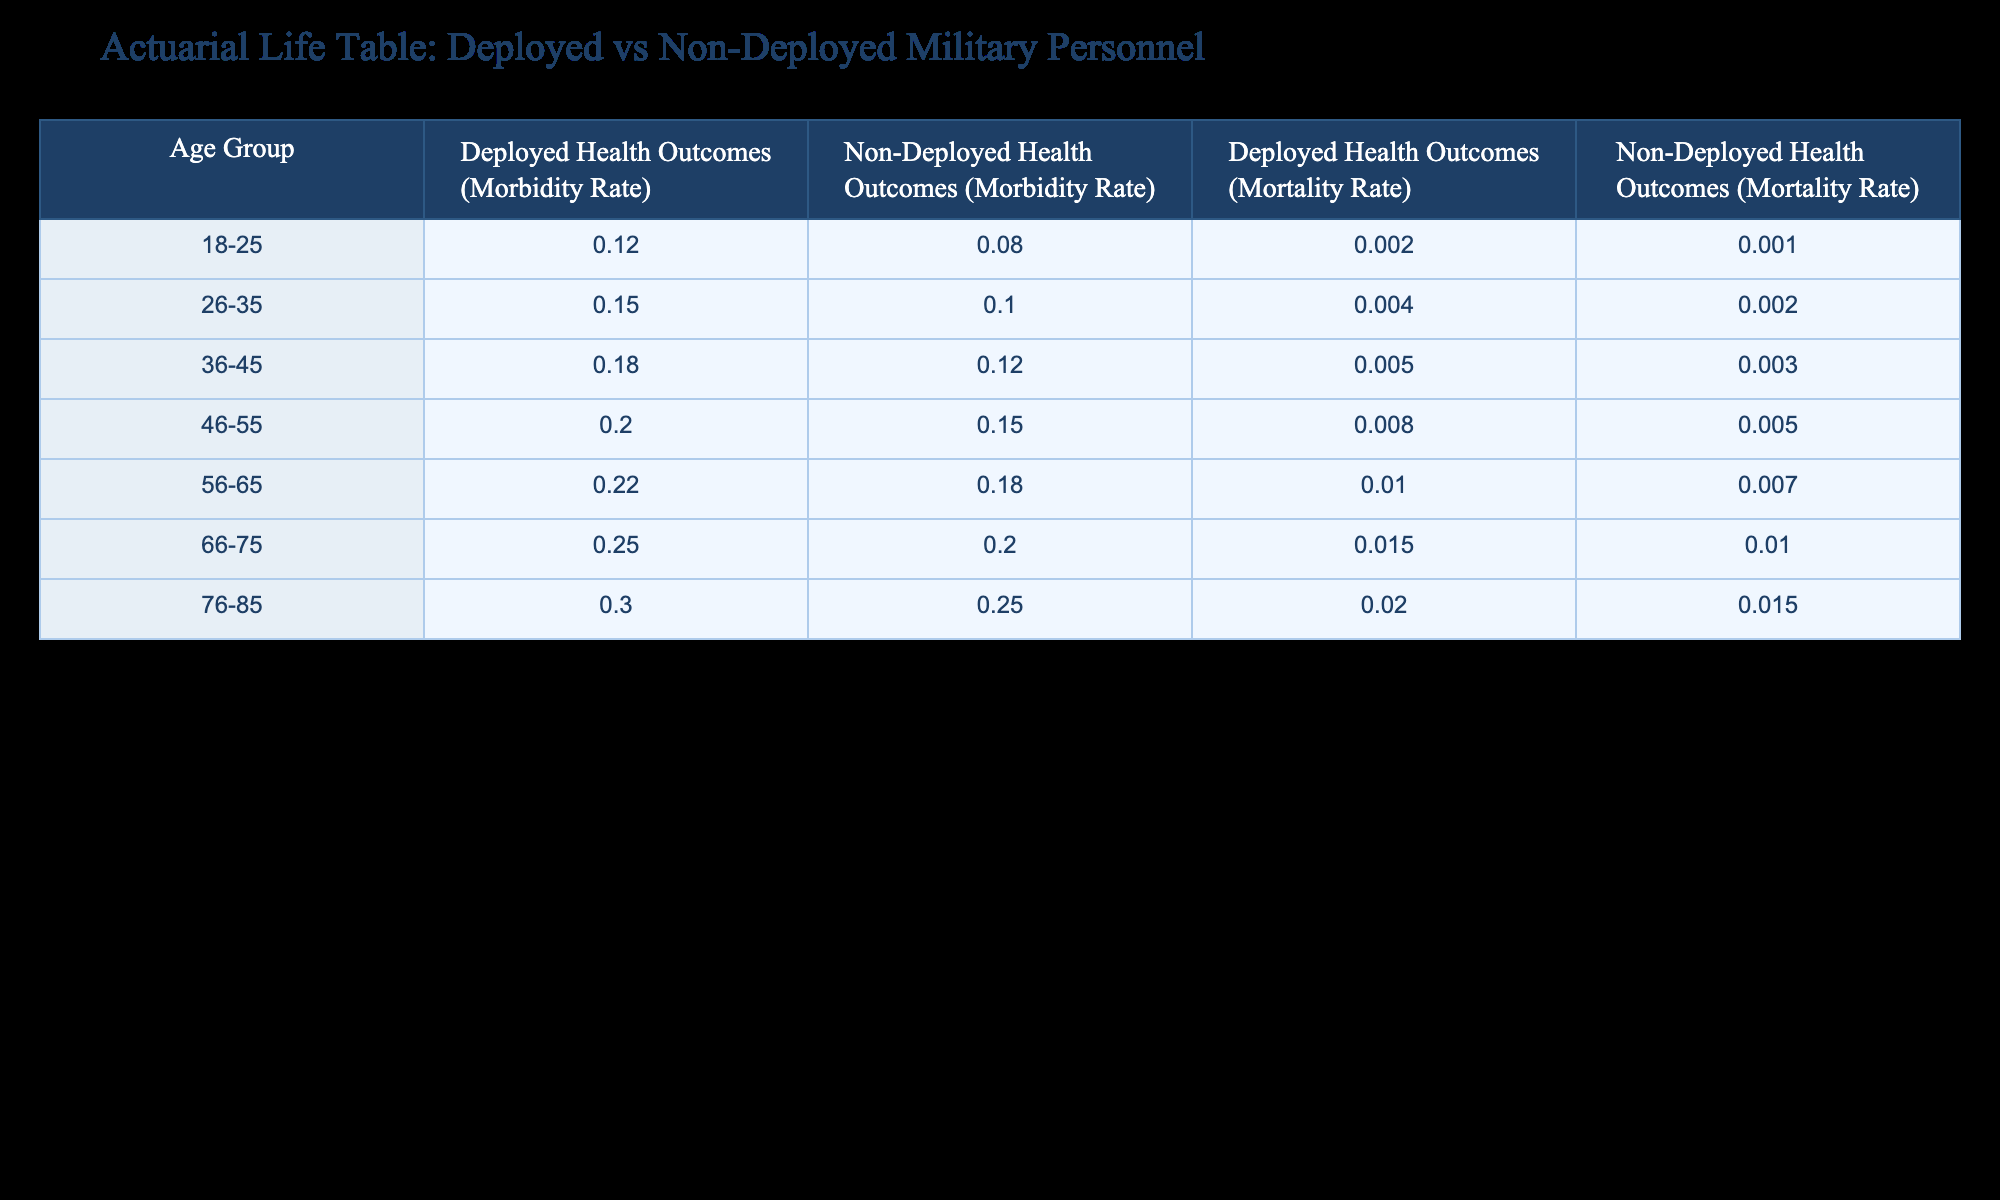What is the morbidity rate for deployed personnel aged 46-55? The table shows that the morbidity rate for deployed personnel in the age group 46-55 is 0.20.
Answer: 0.20 What is the difference in mortality rates between deployed and non-deployed personnel in the age group 56-65? For the age group 56-65, the mortality rate for deployed personnel is 0.010, and for non-deployed personnel, it is 0.007. The difference is 0.010 - 0.007 = 0.003.
Answer: 0.003 Is the morbidity rate higher for any age group among deployed personnel compared to non-deployed personnel? Yes, for every age group listed, the morbidity rates for deployed personnel are higher than for non-deployed personnel.
Answer: Yes What is the average morbidity rate for non-deployed personnel across all age groups? The morbidity rates for non-deployed personnel are 0.08, 0.10, 0.12, 0.15, 0.18, 0.20, and 0.25. Adding them up gives 0.08 + 0.10 + 0.12 + 0.15 + 0.18 + 0.20 + 0.25 = 1.08. There are 7 age groups, so the average is 1.08 / 7 ≈ 0.1543.
Answer: 0.1543 What age group has the highest mortality rate for non-deployed personnel? The table indicates that the highest mortality rate for non-deployed personnel is 0.005 in the age group 76-85.
Answer: 0.015 (in the age group 76-85) 